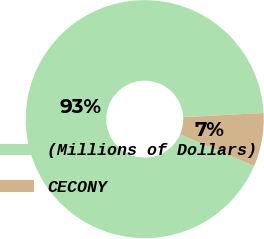Convert chart to OTSL. <chart><loc_0><loc_0><loc_500><loc_500><pie_chart><fcel>(Millions of Dollars)<fcel>CECONY<nl><fcel>92.73%<fcel>7.27%<nl></chart> 